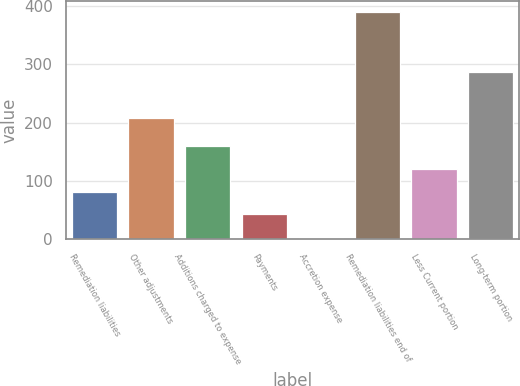<chart> <loc_0><loc_0><loc_500><loc_500><bar_chart><fcel>Remediation liabilities<fcel>Other adjustments<fcel>Additions charged to expense<fcel>Payments<fcel>Accretion expense<fcel>Remediation liabilities end of<fcel>Less Current portion<fcel>Long-term portion<nl><fcel>82.12<fcel>208.1<fcel>159.76<fcel>43.3<fcel>1.7<fcel>389.9<fcel>120.94<fcel>287.1<nl></chart> 